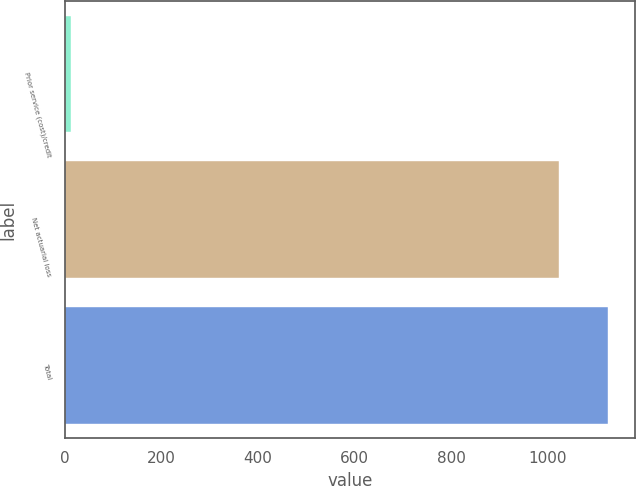Convert chart. <chart><loc_0><loc_0><loc_500><loc_500><bar_chart><fcel>Prior service (cost)/credit<fcel>Net actuarial loss<fcel>Total<nl><fcel>12<fcel>1023<fcel>1125.3<nl></chart> 